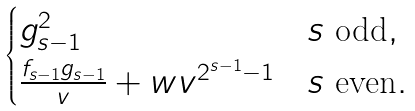Convert formula to latex. <formula><loc_0><loc_0><loc_500><loc_500>\begin{cases} g ^ { 2 } _ { s - 1 } & \text {$s$ odd} , \\ \frac { f _ { s - 1 } g _ { s - 1 } } { v } + w v ^ { 2 ^ { s - 1 } - 1 } & \text {$s$ even} . \end{cases}</formula> 